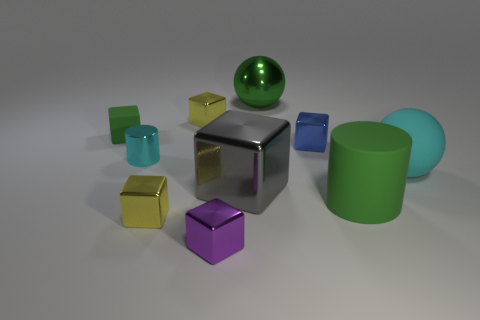What number of other objects are there of the same shape as the tiny blue metal object?
Ensure brevity in your answer.  5. There is a matte cube that is the same size as the cyan cylinder; what is its color?
Ensure brevity in your answer.  Green. What color is the large sphere behind the small green rubber thing?
Offer a terse response. Green. There is a green rubber thing that is in front of the cyan ball; is there a small shiny object behind it?
Offer a very short reply. Yes. Is the shape of the cyan matte thing the same as the matte object in front of the big rubber sphere?
Make the answer very short. No. What size is the rubber thing that is behind the gray cube and to the left of the rubber ball?
Ensure brevity in your answer.  Small. Are there any large green spheres that have the same material as the big cyan sphere?
Your answer should be compact. No. There is a cylinder that is the same color as the shiny sphere; what size is it?
Keep it short and to the point. Large. There is a cylinder right of the yellow metallic block in front of the gray shiny block; what is it made of?
Offer a terse response. Rubber. How many other small cubes are the same color as the tiny rubber block?
Your response must be concise. 0. 